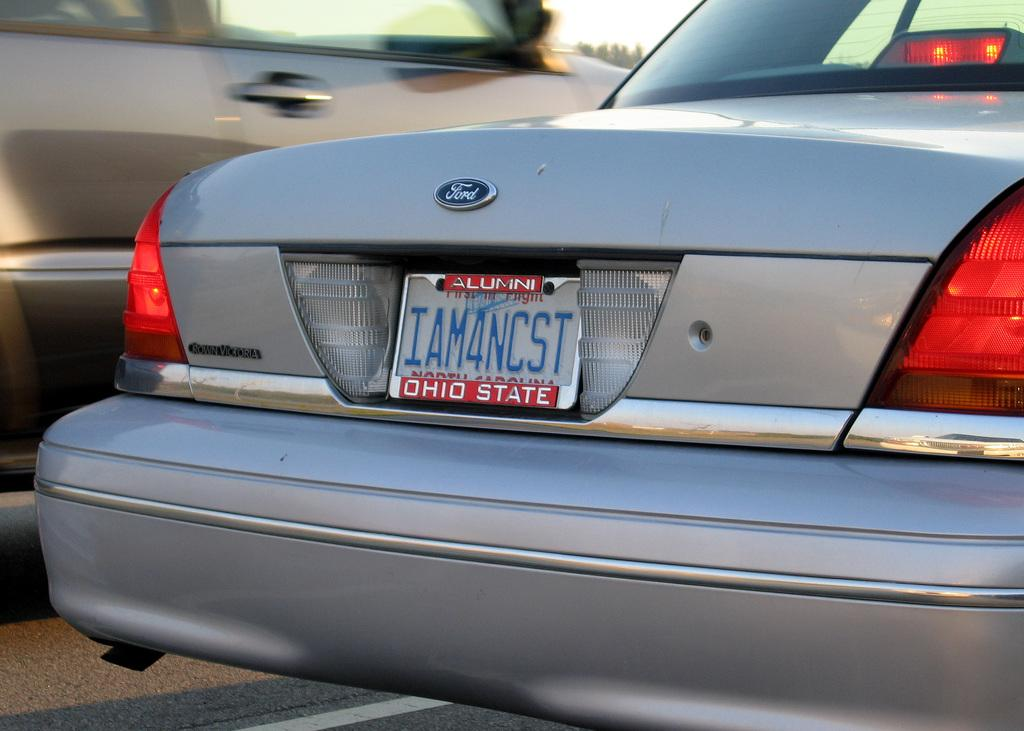How many cars are visible in the image? There are two cars in the image. Where are the cars located? The cars are on the road. What decision does the sheep make in the image? There is no sheep present in the image, so no decision can be made by a sheep. 